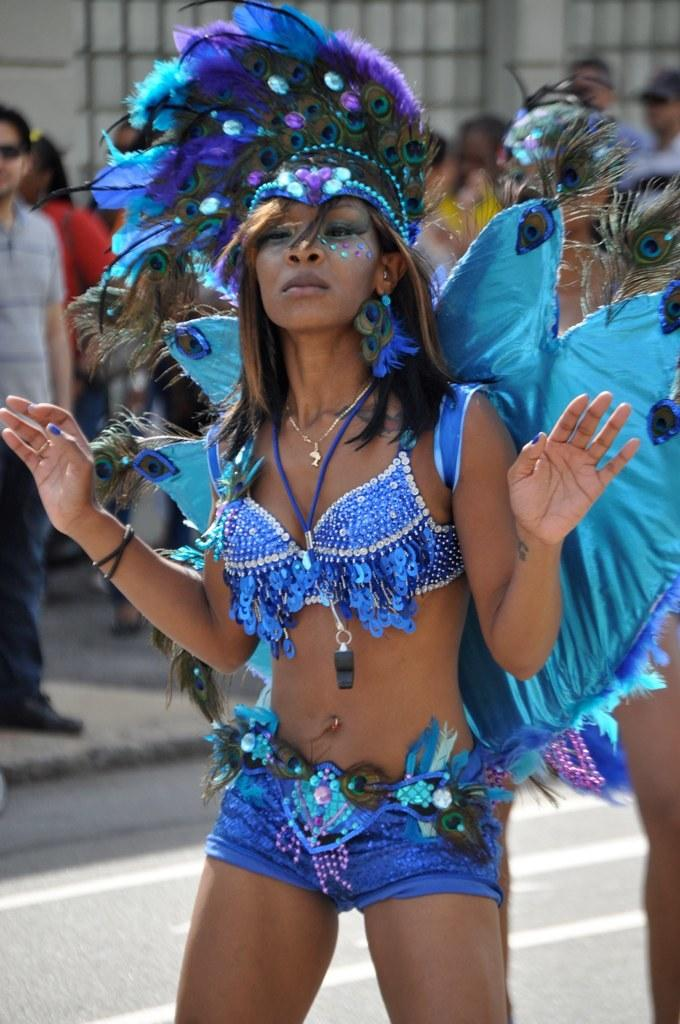Who is the main subject in the image? There is a woman in the image. What is the woman wearing on her head? The woman is wearing a crown. What is the woman doing in the image? The woman is dancing on the road. What can be seen in the background of the image? There is a wall visible in the background. What are the other people in the image doing? There are persons standing on the pavement. What type of structure is the company known for in the image? There is no company or structure mentioned in the image; it features a woman dancing on the road with a crown on her head. 